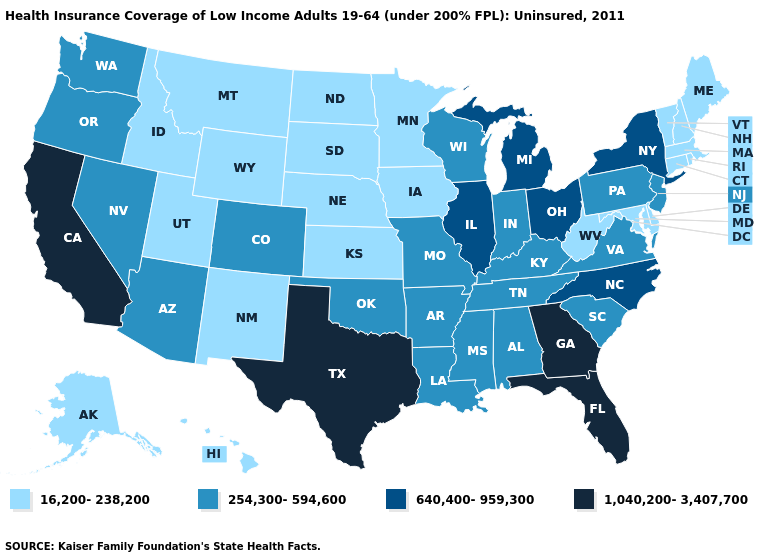Does Massachusetts have a lower value than Pennsylvania?
Be succinct. Yes. Does the first symbol in the legend represent the smallest category?
Be succinct. Yes. Among the states that border Rhode Island , which have the highest value?
Be succinct. Connecticut, Massachusetts. Among the states that border Maine , which have the highest value?
Give a very brief answer. New Hampshire. What is the value of New Jersey?
Short answer required. 254,300-594,600. Does New Mexico have the lowest value in the USA?
Answer briefly. Yes. Which states have the lowest value in the South?
Concise answer only. Delaware, Maryland, West Virginia. How many symbols are there in the legend?
Write a very short answer. 4. Is the legend a continuous bar?
Quick response, please. No. Among the states that border Maryland , does Delaware have the lowest value?
Answer briefly. Yes. Does Vermont have a higher value than Mississippi?
Short answer required. No. What is the highest value in the South ?
Answer briefly. 1,040,200-3,407,700. Among the states that border Missouri , which have the lowest value?
Write a very short answer. Iowa, Kansas, Nebraska. Does Georgia have the lowest value in the South?
Quick response, please. No. Name the states that have a value in the range 16,200-238,200?
Answer briefly. Alaska, Connecticut, Delaware, Hawaii, Idaho, Iowa, Kansas, Maine, Maryland, Massachusetts, Minnesota, Montana, Nebraska, New Hampshire, New Mexico, North Dakota, Rhode Island, South Dakota, Utah, Vermont, West Virginia, Wyoming. 